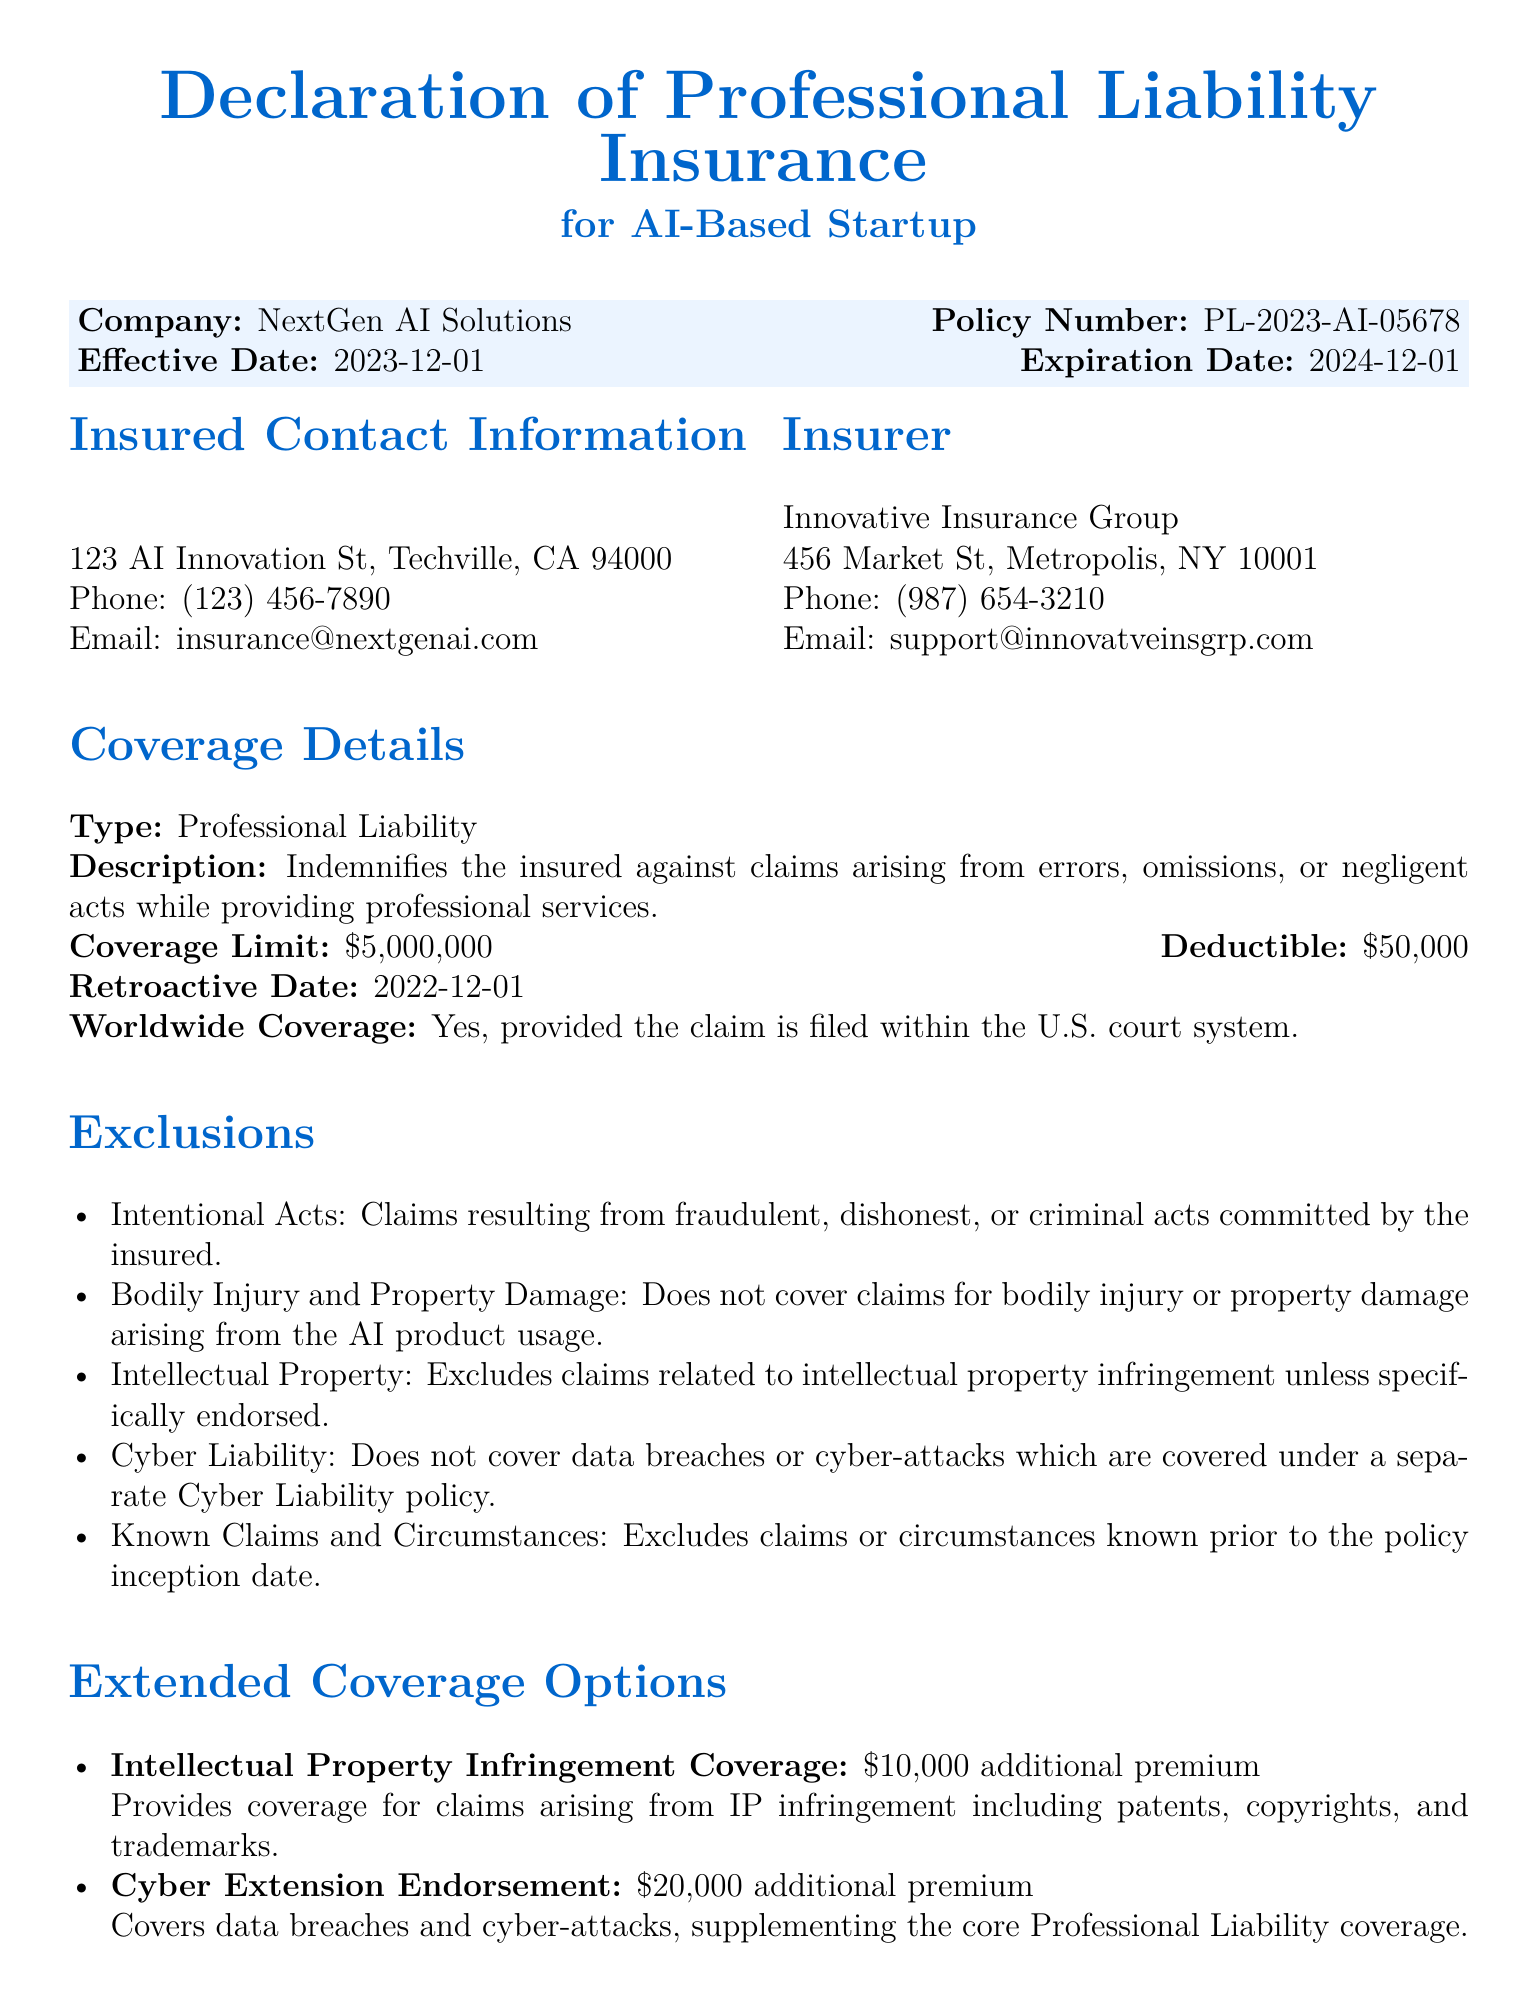What is the name of the insured company? The name of the insured company can be found at the beginning of the document.
Answer: NextGen AI Solutions What is the effective date of the policy? The effective date is listed in the policy information section of the document.
Answer: 2023-12-01 What is the coverage limit for professional liability? The coverage limit is specified in the Coverage Details section.
Answer: $5,000,000 What is the deductible amount? The deductible amount can be found alongside the coverage limit in the Coverage Details section.
Answer: $50,000 What type of coverage is provided under the extended options for IP infringement? This information can be found in the Extended Coverage Options section.
Answer: $10,000 additional premium What are claims related to bodily injury categorized under? The exclusions section specifies what types of claims are not covered.
Answer: Exclusions What does the retroactive date signify? The retroactive date is crucial as it determines claims eligibility according to the insurance coverage terms.
Answer: 2022-12-01 Is worldwide coverage included in the policy? A statement regarding the inclusivity of worldwide coverage is mentioned in the Coverage Details section.
Answer: Yes What is excluded related to cyber incidents? The exclusions section outlines what is not covered concerning cyber risks.
Answer: Data breaches or cyber-attacks What should be referred to for complete terms and conditions? The document indicates where detailed terms can be found.
Answer: The policy document 